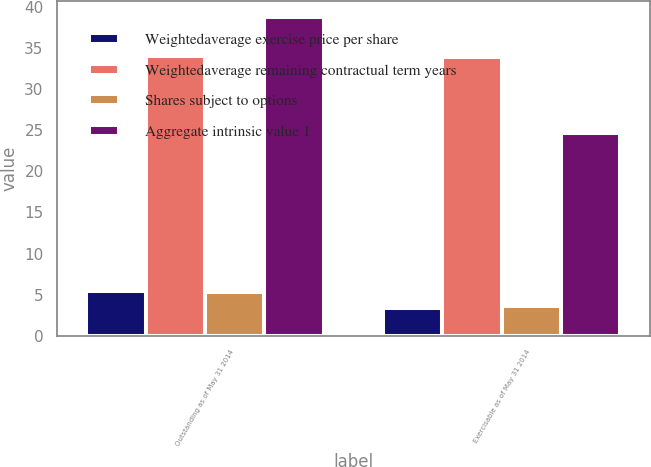<chart> <loc_0><loc_0><loc_500><loc_500><stacked_bar_chart><ecel><fcel>Outstanding as of May 31 2014<fcel>Exercisable as of May 31 2014<nl><fcel>Weightedaverage exercise price per share<fcel>5.4<fcel>3.4<nl><fcel>Weightedaverage remaining contractual term years<fcel>34<fcel>33.87<nl><fcel>Shares subject to options<fcel>5.3<fcel>3.6<nl><fcel>Aggregate intrinsic value 1<fcel>38.7<fcel>24.7<nl></chart> 